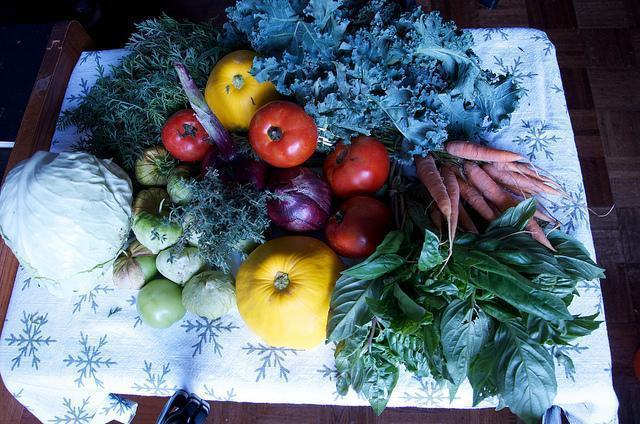What is the large vegetable on the far left?
Answer the question by selecting the correct answer among the 4 following choices.
Options: Yam, cabbage, lettuce, pumpkin. Cabbage. 